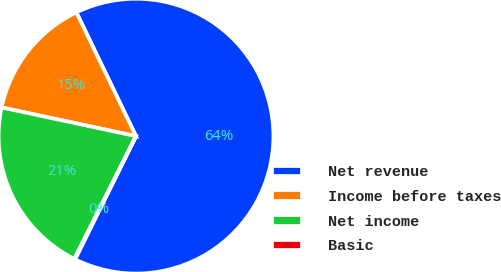Convert chart. <chart><loc_0><loc_0><loc_500><loc_500><pie_chart><fcel>Net revenue<fcel>Income before taxes<fcel>Net income<fcel>Basic<nl><fcel>64.46%<fcel>14.51%<fcel>20.94%<fcel>0.1%<nl></chart> 